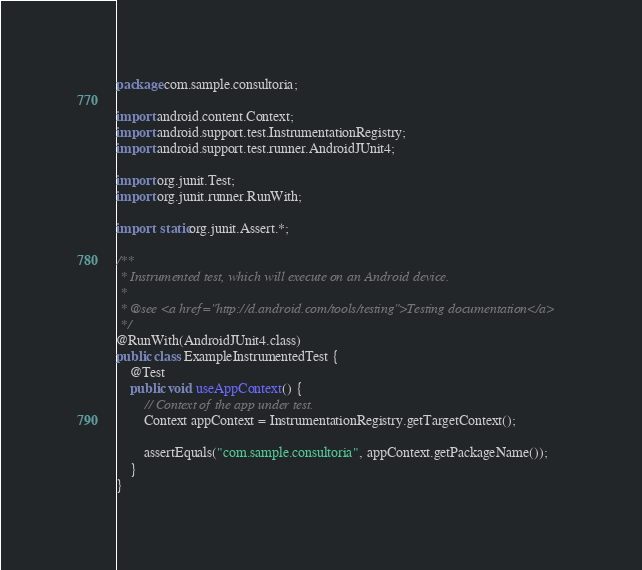Convert code to text. <code><loc_0><loc_0><loc_500><loc_500><_Java_>package com.sample.consultoria;

import android.content.Context;
import android.support.test.InstrumentationRegistry;
import android.support.test.runner.AndroidJUnit4;

import org.junit.Test;
import org.junit.runner.RunWith;

import static org.junit.Assert.*;

/**
 * Instrumented test, which will execute on an Android device.
 *
 * @see <a href="http://d.android.com/tools/testing">Testing documentation</a>
 */
@RunWith(AndroidJUnit4.class)
public class ExampleInstrumentedTest {
    @Test
    public void useAppContext() {
        // Context of the app under test.
        Context appContext = InstrumentationRegistry.getTargetContext();

        assertEquals("com.sample.consultoria", appContext.getPackageName());
    }
}
</code> 